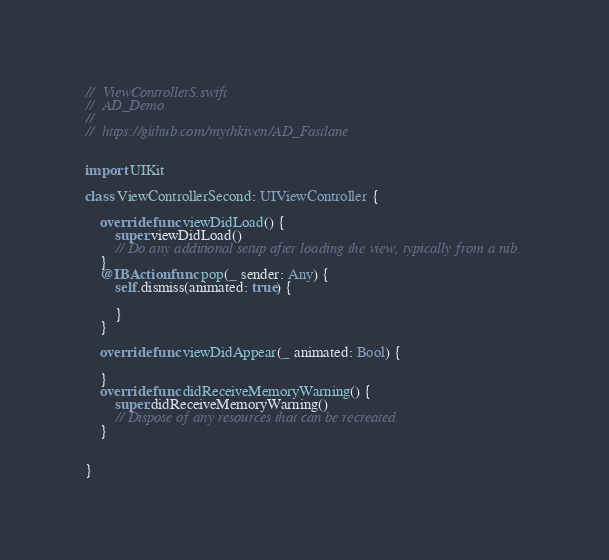<code> <loc_0><loc_0><loc_500><loc_500><_Swift_>//  ViewControllerS.swift
//  AD_Demo
//
//  https://github.com/mythkiven/AD_Fastlane


import UIKit

class ViewControllerSecond: UIViewController {
    
    override func viewDidLoad() {
        super.viewDidLoad()
        // Do any additional setup after loading the view, typically from a nib.
    }
    @IBAction func pop(_ sender: Any) {
        self.dismiss(animated: true) { 
            
        }
    }
    
    override func viewDidAppear(_ animated: Bool) {
        
    }
    override func didReceiveMemoryWarning() {
        super.didReceiveMemoryWarning()
        // Dispose of any resources that can be recreated.
    }
    
    
}

</code> 